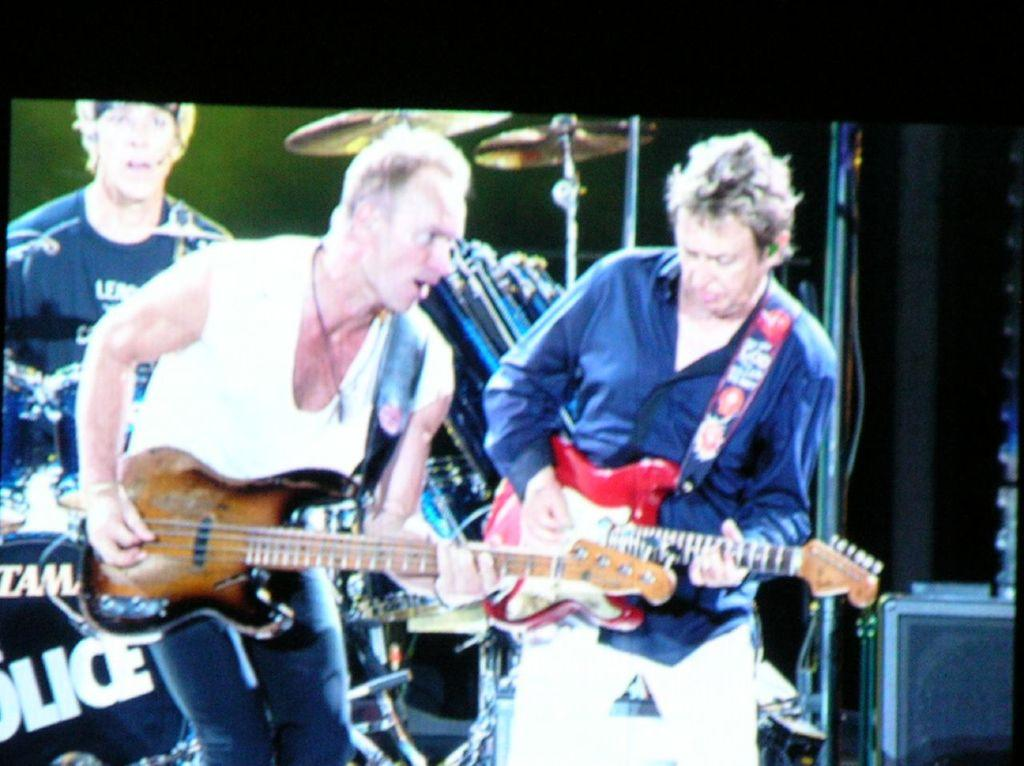What are the two people in the image doing? The two people in the image are playing guitar. Can you describe the man standing behind them? There is a man standing behind them on the left side of the image. What other musical instrument can be seen in the image? There is a drum visible at the top of the image. What type of copper foot can be seen supporting the guitar in the image? There is no copper foot supporting the guitar in the image; the guitars are being played by the two people. 